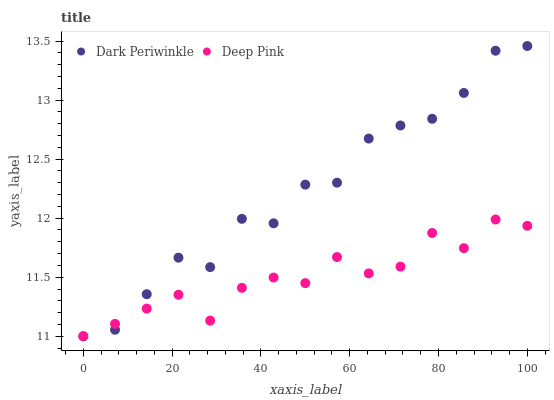Does Deep Pink have the minimum area under the curve?
Answer yes or no. Yes. Does Dark Periwinkle have the maximum area under the curve?
Answer yes or no. Yes. Does Dark Periwinkle have the minimum area under the curve?
Answer yes or no. No. Is Deep Pink the smoothest?
Answer yes or no. Yes. Is Dark Periwinkle the roughest?
Answer yes or no. Yes. Is Dark Periwinkle the smoothest?
Answer yes or no. No. Does Deep Pink have the lowest value?
Answer yes or no. Yes. Does Dark Periwinkle have the highest value?
Answer yes or no. Yes. Does Deep Pink intersect Dark Periwinkle?
Answer yes or no. Yes. Is Deep Pink less than Dark Periwinkle?
Answer yes or no. No. Is Deep Pink greater than Dark Periwinkle?
Answer yes or no. No. 